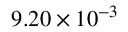<formula> <loc_0><loc_0><loc_500><loc_500>9 . 2 0 \times 1 0 ^ { - 3 }</formula> 